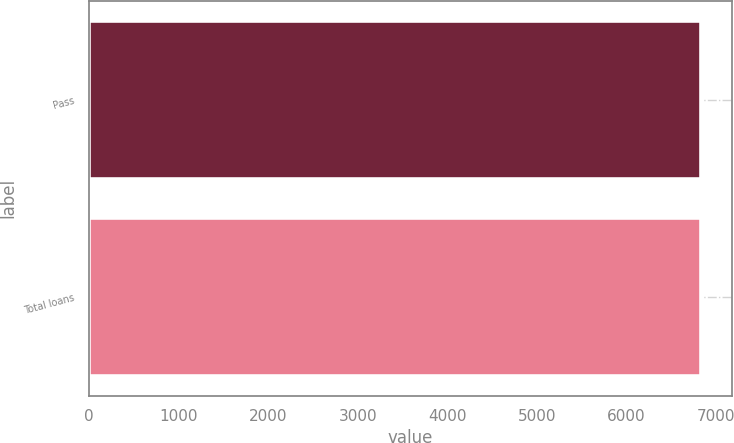Convert chart. <chart><loc_0><loc_0><loc_500><loc_500><bar_chart><fcel>Pass<fcel>Total loans<nl><fcel>6839<fcel>6839.1<nl></chart> 